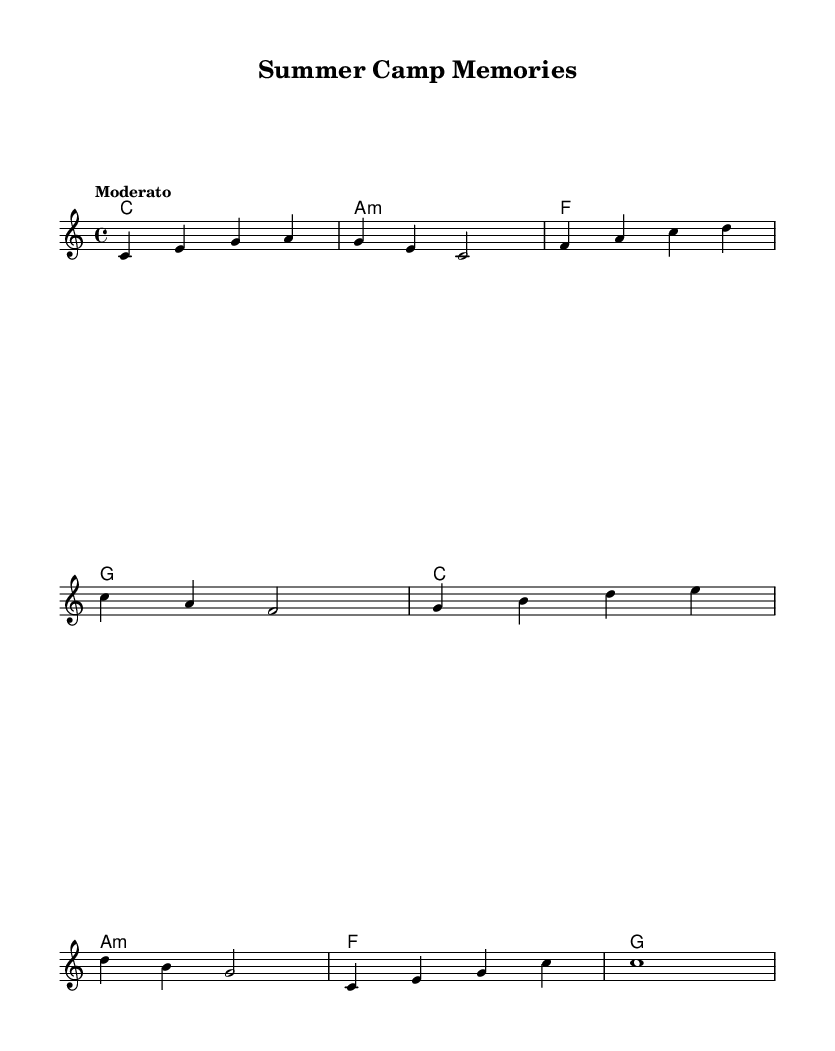What is the key signature of this music? The key signature is C major, which has no sharps or flats.
Answer: C major What is the time signature of this music? The time signature is indicated at the beginning of the score as 4/4, meaning there are four beats in each measure.
Answer: 4/4 What is the tempo marking of this music? The tempo marking stated in the score is "Moderato," suggesting a moderate speed.
Answer: Moderato How many measures are in the melody? Counting the bars in the melody portion, there are eight measures total, marked by the vertical bar lines in the notation.
Answer: 8 What is the first note of the melody? The first note in the melody is C, which is indicated at the beginning of the piece.
Answer: C Which chord appears in the second measure of the harmony? The second measure of the harmony has the A minor chord, represented by the chord names in the score.
Answer: A minor What is the last note of the melody? The last note of the melody is C, as indicated in the final measure, where it holds for the entire measure.
Answer: C 